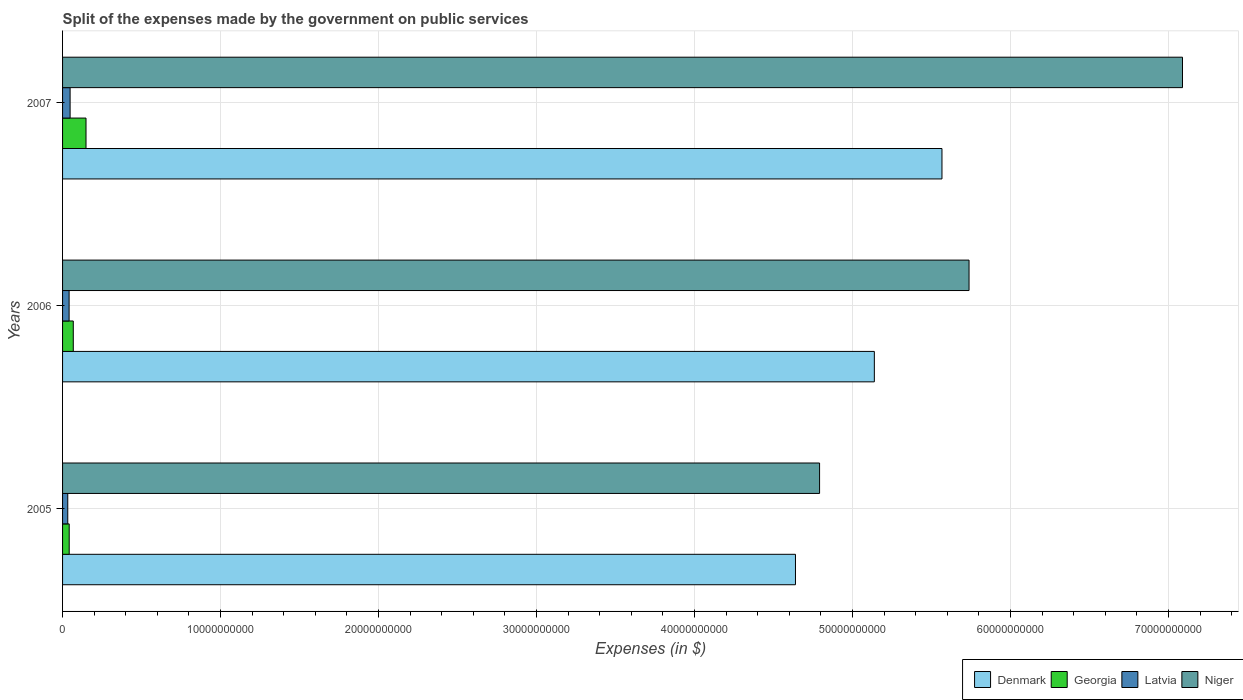Are the number of bars per tick equal to the number of legend labels?
Ensure brevity in your answer.  Yes. How many bars are there on the 1st tick from the top?
Keep it short and to the point. 4. How many bars are there on the 2nd tick from the bottom?
Offer a terse response. 4. What is the label of the 1st group of bars from the top?
Provide a short and direct response. 2007. What is the expenses made by the government on public services in Latvia in 2005?
Your response must be concise. 3.30e+08. Across all years, what is the maximum expenses made by the government on public services in Niger?
Your answer should be compact. 7.09e+1. Across all years, what is the minimum expenses made by the government on public services in Denmark?
Your response must be concise. 4.64e+1. In which year was the expenses made by the government on public services in Denmark maximum?
Your answer should be very brief. 2007. In which year was the expenses made by the government on public services in Niger minimum?
Your answer should be very brief. 2005. What is the total expenses made by the government on public services in Denmark in the graph?
Ensure brevity in your answer.  1.53e+11. What is the difference between the expenses made by the government on public services in Niger in 2005 and that in 2006?
Keep it short and to the point. -9.46e+09. What is the difference between the expenses made by the government on public services in Georgia in 2006 and the expenses made by the government on public services in Denmark in 2007?
Provide a succinct answer. -5.50e+1. What is the average expenses made by the government on public services in Latvia per year?
Provide a short and direct response. 4.07e+08. In the year 2007, what is the difference between the expenses made by the government on public services in Georgia and expenses made by the government on public services in Niger?
Offer a terse response. -6.94e+1. In how many years, is the expenses made by the government on public services in Denmark greater than 12000000000 $?
Offer a very short reply. 3. What is the ratio of the expenses made by the government on public services in Georgia in 2006 to that in 2007?
Provide a short and direct response. 0.46. Is the expenses made by the government on public services in Latvia in 2005 less than that in 2007?
Keep it short and to the point. Yes. What is the difference between the highest and the second highest expenses made by the government on public services in Latvia?
Your response must be concise. 6.30e+07. What is the difference between the highest and the lowest expenses made by the government on public services in Georgia?
Provide a short and direct response. 1.06e+09. In how many years, is the expenses made by the government on public services in Latvia greater than the average expenses made by the government on public services in Latvia taken over all years?
Your answer should be compact. 2. Is it the case that in every year, the sum of the expenses made by the government on public services in Denmark and expenses made by the government on public services in Niger is greater than the sum of expenses made by the government on public services in Georgia and expenses made by the government on public services in Latvia?
Make the answer very short. No. What does the 1st bar from the top in 2006 represents?
Provide a short and direct response. Niger. What does the 3rd bar from the bottom in 2007 represents?
Ensure brevity in your answer.  Latvia. Are all the bars in the graph horizontal?
Provide a succinct answer. Yes. How many years are there in the graph?
Offer a very short reply. 3. What is the difference between two consecutive major ticks on the X-axis?
Offer a terse response. 1.00e+1. Are the values on the major ticks of X-axis written in scientific E-notation?
Ensure brevity in your answer.  No. Does the graph contain grids?
Your response must be concise. Yes. How many legend labels are there?
Ensure brevity in your answer.  4. How are the legend labels stacked?
Ensure brevity in your answer.  Horizontal. What is the title of the graph?
Your response must be concise. Split of the expenses made by the government on public services. What is the label or title of the X-axis?
Your answer should be very brief. Expenses (in $). What is the label or title of the Y-axis?
Provide a short and direct response. Years. What is the Expenses (in $) of Denmark in 2005?
Your answer should be very brief. 4.64e+1. What is the Expenses (in $) in Georgia in 2005?
Provide a short and direct response. 4.20e+08. What is the Expenses (in $) in Latvia in 2005?
Provide a short and direct response. 3.30e+08. What is the Expenses (in $) of Niger in 2005?
Your answer should be very brief. 4.79e+1. What is the Expenses (in $) in Denmark in 2006?
Provide a short and direct response. 5.14e+1. What is the Expenses (in $) of Georgia in 2006?
Your answer should be very brief. 6.78e+08. What is the Expenses (in $) in Latvia in 2006?
Offer a very short reply. 4.14e+08. What is the Expenses (in $) in Niger in 2006?
Offer a very short reply. 5.74e+1. What is the Expenses (in $) of Denmark in 2007?
Offer a very short reply. 5.57e+1. What is the Expenses (in $) of Georgia in 2007?
Ensure brevity in your answer.  1.48e+09. What is the Expenses (in $) in Latvia in 2007?
Keep it short and to the point. 4.77e+08. What is the Expenses (in $) of Niger in 2007?
Ensure brevity in your answer.  7.09e+1. Across all years, what is the maximum Expenses (in $) of Denmark?
Provide a short and direct response. 5.57e+1. Across all years, what is the maximum Expenses (in $) of Georgia?
Provide a short and direct response. 1.48e+09. Across all years, what is the maximum Expenses (in $) of Latvia?
Your response must be concise. 4.77e+08. Across all years, what is the maximum Expenses (in $) of Niger?
Your answer should be compact. 7.09e+1. Across all years, what is the minimum Expenses (in $) in Denmark?
Your answer should be compact. 4.64e+1. Across all years, what is the minimum Expenses (in $) of Georgia?
Offer a very short reply. 4.20e+08. Across all years, what is the minimum Expenses (in $) of Latvia?
Your answer should be compact. 3.30e+08. Across all years, what is the minimum Expenses (in $) of Niger?
Ensure brevity in your answer.  4.79e+1. What is the total Expenses (in $) in Denmark in the graph?
Keep it short and to the point. 1.53e+11. What is the total Expenses (in $) of Georgia in the graph?
Your answer should be compact. 2.58e+09. What is the total Expenses (in $) of Latvia in the graph?
Offer a terse response. 1.22e+09. What is the total Expenses (in $) of Niger in the graph?
Keep it short and to the point. 1.76e+11. What is the difference between the Expenses (in $) in Denmark in 2005 and that in 2006?
Provide a succinct answer. -4.99e+09. What is the difference between the Expenses (in $) in Georgia in 2005 and that in 2006?
Your response must be concise. -2.58e+08. What is the difference between the Expenses (in $) of Latvia in 2005 and that in 2006?
Provide a short and direct response. -8.45e+07. What is the difference between the Expenses (in $) in Niger in 2005 and that in 2006?
Your answer should be compact. -9.46e+09. What is the difference between the Expenses (in $) in Denmark in 2005 and that in 2007?
Make the answer very short. -9.27e+09. What is the difference between the Expenses (in $) in Georgia in 2005 and that in 2007?
Your response must be concise. -1.06e+09. What is the difference between the Expenses (in $) of Latvia in 2005 and that in 2007?
Provide a succinct answer. -1.47e+08. What is the difference between the Expenses (in $) of Niger in 2005 and that in 2007?
Your answer should be very brief. -2.30e+1. What is the difference between the Expenses (in $) of Denmark in 2006 and that in 2007?
Provide a short and direct response. -4.28e+09. What is the difference between the Expenses (in $) in Georgia in 2006 and that in 2007?
Give a very brief answer. -8.05e+08. What is the difference between the Expenses (in $) of Latvia in 2006 and that in 2007?
Your response must be concise. -6.30e+07. What is the difference between the Expenses (in $) in Niger in 2006 and that in 2007?
Your answer should be compact. -1.35e+1. What is the difference between the Expenses (in $) in Denmark in 2005 and the Expenses (in $) in Georgia in 2006?
Provide a succinct answer. 4.57e+1. What is the difference between the Expenses (in $) of Denmark in 2005 and the Expenses (in $) of Latvia in 2006?
Offer a very short reply. 4.60e+1. What is the difference between the Expenses (in $) of Denmark in 2005 and the Expenses (in $) of Niger in 2006?
Keep it short and to the point. -1.10e+1. What is the difference between the Expenses (in $) in Georgia in 2005 and the Expenses (in $) in Latvia in 2006?
Offer a terse response. 6.20e+06. What is the difference between the Expenses (in $) in Georgia in 2005 and the Expenses (in $) in Niger in 2006?
Your answer should be very brief. -5.70e+1. What is the difference between the Expenses (in $) of Latvia in 2005 and the Expenses (in $) of Niger in 2006?
Your answer should be very brief. -5.70e+1. What is the difference between the Expenses (in $) of Denmark in 2005 and the Expenses (in $) of Georgia in 2007?
Your answer should be very brief. 4.49e+1. What is the difference between the Expenses (in $) in Denmark in 2005 and the Expenses (in $) in Latvia in 2007?
Provide a short and direct response. 4.59e+1. What is the difference between the Expenses (in $) of Denmark in 2005 and the Expenses (in $) of Niger in 2007?
Your response must be concise. -2.45e+1. What is the difference between the Expenses (in $) of Georgia in 2005 and the Expenses (in $) of Latvia in 2007?
Your answer should be very brief. -5.68e+07. What is the difference between the Expenses (in $) in Georgia in 2005 and the Expenses (in $) in Niger in 2007?
Offer a terse response. -7.05e+1. What is the difference between the Expenses (in $) in Latvia in 2005 and the Expenses (in $) in Niger in 2007?
Give a very brief answer. -7.06e+1. What is the difference between the Expenses (in $) of Denmark in 2006 and the Expenses (in $) of Georgia in 2007?
Your answer should be compact. 4.99e+1. What is the difference between the Expenses (in $) in Denmark in 2006 and the Expenses (in $) in Latvia in 2007?
Your answer should be compact. 5.09e+1. What is the difference between the Expenses (in $) of Denmark in 2006 and the Expenses (in $) of Niger in 2007?
Your response must be concise. -1.95e+1. What is the difference between the Expenses (in $) of Georgia in 2006 and the Expenses (in $) of Latvia in 2007?
Your response must be concise. 2.02e+08. What is the difference between the Expenses (in $) of Georgia in 2006 and the Expenses (in $) of Niger in 2007?
Your answer should be very brief. -7.02e+1. What is the difference between the Expenses (in $) in Latvia in 2006 and the Expenses (in $) in Niger in 2007?
Offer a terse response. -7.05e+1. What is the average Expenses (in $) in Denmark per year?
Your answer should be very brief. 5.11e+1. What is the average Expenses (in $) of Georgia per year?
Offer a terse response. 8.61e+08. What is the average Expenses (in $) of Latvia per year?
Provide a short and direct response. 4.07e+08. What is the average Expenses (in $) in Niger per year?
Give a very brief answer. 5.87e+1. In the year 2005, what is the difference between the Expenses (in $) in Denmark and Expenses (in $) in Georgia?
Offer a very short reply. 4.60e+1. In the year 2005, what is the difference between the Expenses (in $) in Denmark and Expenses (in $) in Latvia?
Your answer should be very brief. 4.61e+1. In the year 2005, what is the difference between the Expenses (in $) in Denmark and Expenses (in $) in Niger?
Give a very brief answer. -1.53e+09. In the year 2005, what is the difference between the Expenses (in $) in Georgia and Expenses (in $) in Latvia?
Provide a short and direct response. 9.07e+07. In the year 2005, what is the difference between the Expenses (in $) in Georgia and Expenses (in $) in Niger?
Offer a very short reply. -4.75e+1. In the year 2005, what is the difference between the Expenses (in $) of Latvia and Expenses (in $) of Niger?
Your answer should be very brief. -4.76e+1. In the year 2006, what is the difference between the Expenses (in $) in Denmark and Expenses (in $) in Georgia?
Provide a short and direct response. 5.07e+1. In the year 2006, what is the difference between the Expenses (in $) in Denmark and Expenses (in $) in Latvia?
Make the answer very short. 5.10e+1. In the year 2006, what is the difference between the Expenses (in $) in Denmark and Expenses (in $) in Niger?
Your answer should be very brief. -5.99e+09. In the year 2006, what is the difference between the Expenses (in $) of Georgia and Expenses (in $) of Latvia?
Provide a short and direct response. 2.64e+08. In the year 2006, what is the difference between the Expenses (in $) of Georgia and Expenses (in $) of Niger?
Keep it short and to the point. -5.67e+1. In the year 2006, what is the difference between the Expenses (in $) of Latvia and Expenses (in $) of Niger?
Your answer should be compact. -5.70e+1. In the year 2007, what is the difference between the Expenses (in $) of Denmark and Expenses (in $) of Georgia?
Make the answer very short. 5.42e+1. In the year 2007, what is the difference between the Expenses (in $) in Denmark and Expenses (in $) in Latvia?
Your answer should be very brief. 5.52e+1. In the year 2007, what is the difference between the Expenses (in $) of Denmark and Expenses (in $) of Niger?
Give a very brief answer. -1.52e+1. In the year 2007, what is the difference between the Expenses (in $) of Georgia and Expenses (in $) of Latvia?
Keep it short and to the point. 1.01e+09. In the year 2007, what is the difference between the Expenses (in $) of Georgia and Expenses (in $) of Niger?
Ensure brevity in your answer.  -6.94e+1. In the year 2007, what is the difference between the Expenses (in $) in Latvia and Expenses (in $) in Niger?
Your answer should be compact. -7.04e+1. What is the ratio of the Expenses (in $) in Denmark in 2005 to that in 2006?
Offer a very short reply. 0.9. What is the ratio of the Expenses (in $) of Georgia in 2005 to that in 2006?
Provide a succinct answer. 0.62. What is the ratio of the Expenses (in $) in Latvia in 2005 to that in 2006?
Offer a terse response. 0.8. What is the ratio of the Expenses (in $) of Niger in 2005 to that in 2006?
Your answer should be compact. 0.84. What is the ratio of the Expenses (in $) of Denmark in 2005 to that in 2007?
Offer a terse response. 0.83. What is the ratio of the Expenses (in $) of Georgia in 2005 to that in 2007?
Offer a very short reply. 0.28. What is the ratio of the Expenses (in $) in Latvia in 2005 to that in 2007?
Offer a very short reply. 0.69. What is the ratio of the Expenses (in $) of Niger in 2005 to that in 2007?
Your response must be concise. 0.68. What is the ratio of the Expenses (in $) of Georgia in 2006 to that in 2007?
Make the answer very short. 0.46. What is the ratio of the Expenses (in $) of Latvia in 2006 to that in 2007?
Offer a terse response. 0.87. What is the ratio of the Expenses (in $) of Niger in 2006 to that in 2007?
Provide a short and direct response. 0.81. What is the difference between the highest and the second highest Expenses (in $) of Denmark?
Provide a short and direct response. 4.28e+09. What is the difference between the highest and the second highest Expenses (in $) of Georgia?
Give a very brief answer. 8.05e+08. What is the difference between the highest and the second highest Expenses (in $) in Latvia?
Provide a succinct answer. 6.30e+07. What is the difference between the highest and the second highest Expenses (in $) in Niger?
Keep it short and to the point. 1.35e+1. What is the difference between the highest and the lowest Expenses (in $) of Denmark?
Provide a short and direct response. 9.27e+09. What is the difference between the highest and the lowest Expenses (in $) of Georgia?
Offer a very short reply. 1.06e+09. What is the difference between the highest and the lowest Expenses (in $) in Latvia?
Give a very brief answer. 1.47e+08. What is the difference between the highest and the lowest Expenses (in $) of Niger?
Your response must be concise. 2.30e+1. 